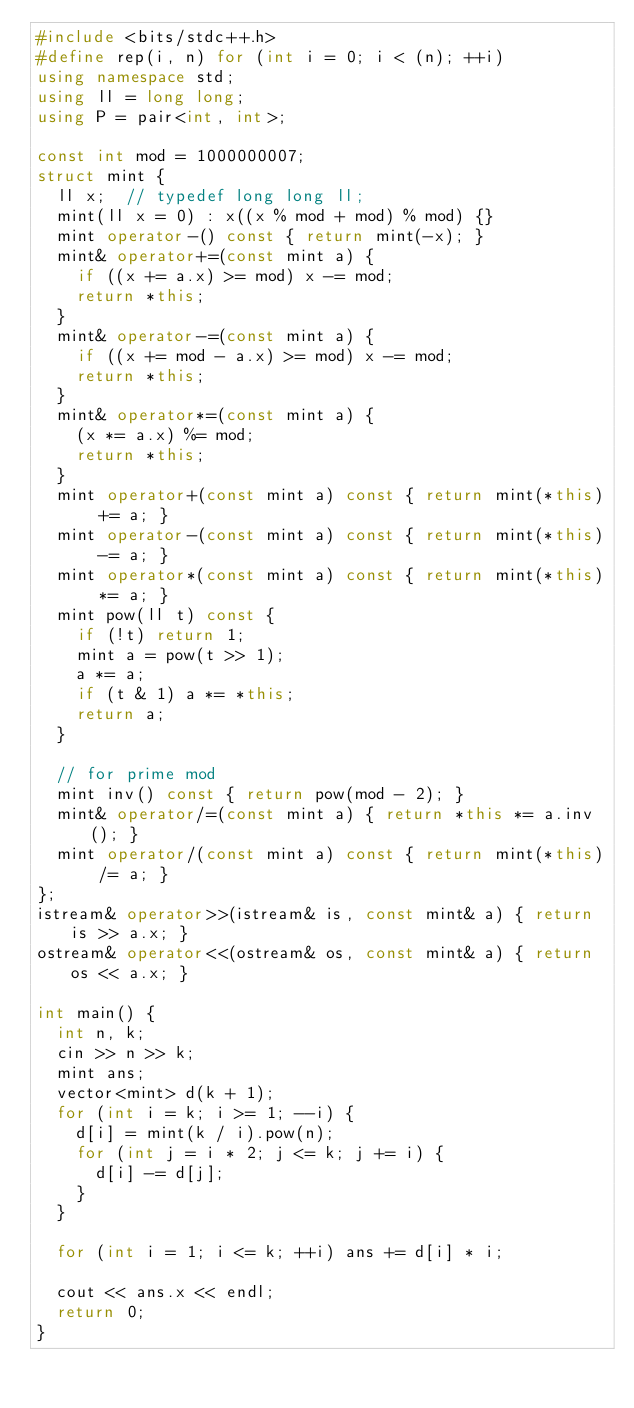<code> <loc_0><loc_0><loc_500><loc_500><_C++_>#include <bits/stdc++.h>
#define rep(i, n) for (int i = 0; i < (n); ++i)
using namespace std;
using ll = long long;
using P = pair<int, int>;

const int mod = 1000000007;
struct mint {
  ll x;  // typedef long long ll;
  mint(ll x = 0) : x((x % mod + mod) % mod) {}
  mint operator-() const { return mint(-x); }
  mint& operator+=(const mint a) {
    if ((x += a.x) >= mod) x -= mod;
    return *this;
  }
  mint& operator-=(const mint a) {
    if ((x += mod - a.x) >= mod) x -= mod;
    return *this;
  }
  mint& operator*=(const mint a) {
    (x *= a.x) %= mod;
    return *this;
  }
  mint operator+(const mint a) const { return mint(*this) += a; }
  mint operator-(const mint a) const { return mint(*this) -= a; }
  mint operator*(const mint a) const { return mint(*this) *= a; }
  mint pow(ll t) const {
    if (!t) return 1;
    mint a = pow(t >> 1);
    a *= a;
    if (t & 1) a *= *this;
    return a;
  }

  // for prime mod
  mint inv() const { return pow(mod - 2); }
  mint& operator/=(const mint a) { return *this *= a.inv(); }
  mint operator/(const mint a) const { return mint(*this) /= a; }
};
istream& operator>>(istream& is, const mint& a) { return is >> a.x; }
ostream& operator<<(ostream& os, const mint& a) { return os << a.x; }

int main() {
  int n, k;
  cin >> n >> k;
  mint ans;
  vector<mint> d(k + 1);
  for (int i = k; i >= 1; --i) {
    d[i] = mint(k / i).pow(n);
    for (int j = i * 2; j <= k; j += i) {
      d[i] -= d[j];
    }
  }

  for (int i = 1; i <= k; ++i) ans += d[i] * i;

  cout << ans.x << endl;
  return 0;
}</code> 